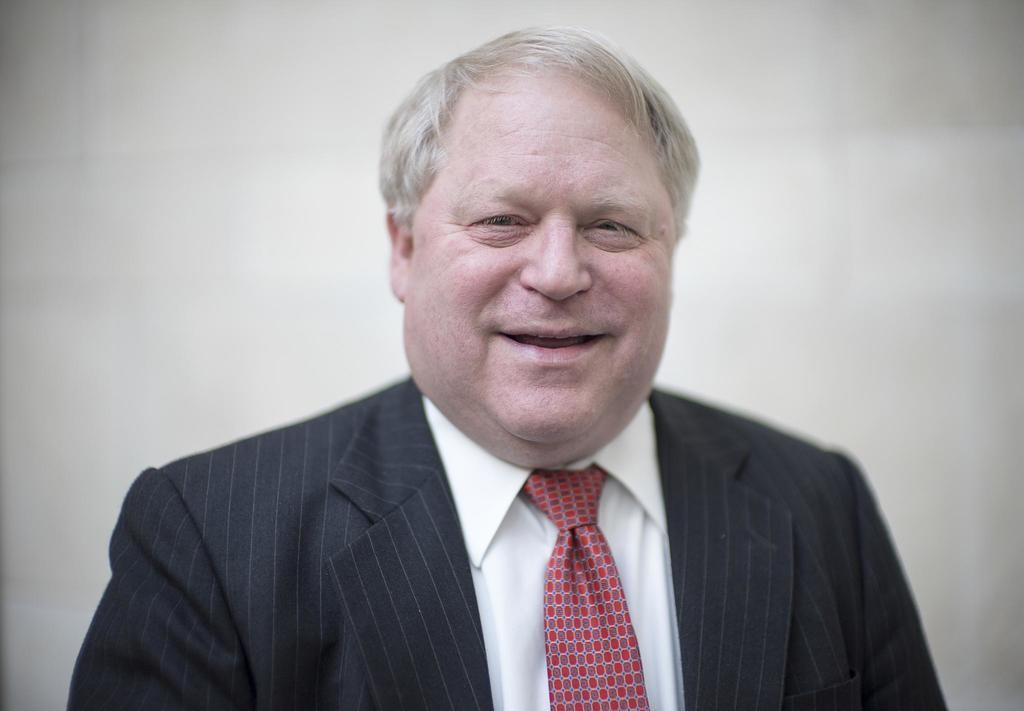What is the main subject of the picture? The main subject of the picture is a man. What is the man wearing on his upper body? The man is wearing a white shirt and a black blazer. What color tie is the man wearing? The man is wearing a red tie. What is the man's facial expression in the image? The man is smiling in the image. What color is the background of the image? The background of the image is white in color. How many eggs can be seen in the man's hand in the image? There are no eggs present in the image; the man is not holding any eggs. What type of dock is visible in the background of the image? There is no dock present in the image; the background is white in color. 